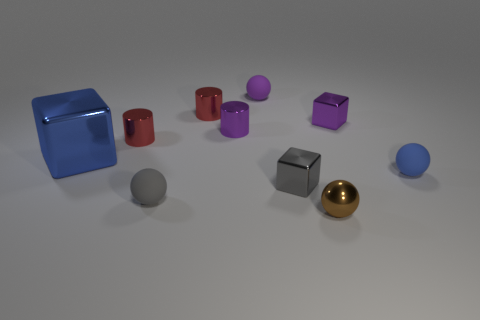Subtract 1 spheres. How many spheres are left? 3 Subtract all cylinders. How many objects are left? 7 Add 4 blue objects. How many blue objects exist? 6 Subtract 0 yellow cylinders. How many objects are left? 10 Subtract all yellow metal objects. Subtract all blue metal objects. How many objects are left? 9 Add 3 blue metal things. How many blue metal things are left? 4 